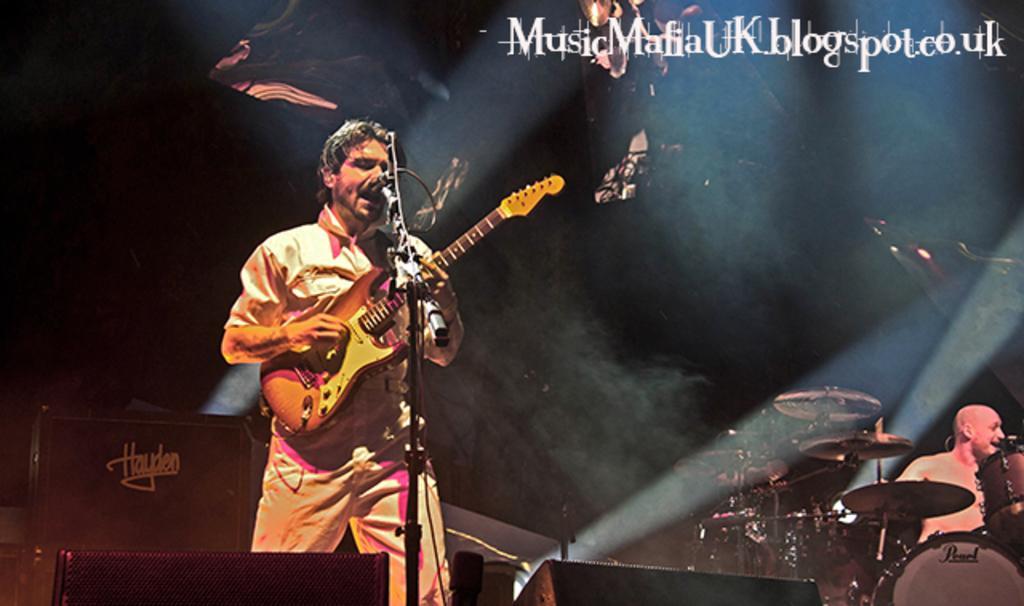In one or two sentences, can you explain what this image depicts? In this picture there is a man who is playing guitar and singing on the mic. At the bottom we can see the speakers. On the right there is a bald man who is playing the drums. At the top we can see the watermark. On the left we can see the darkness. 